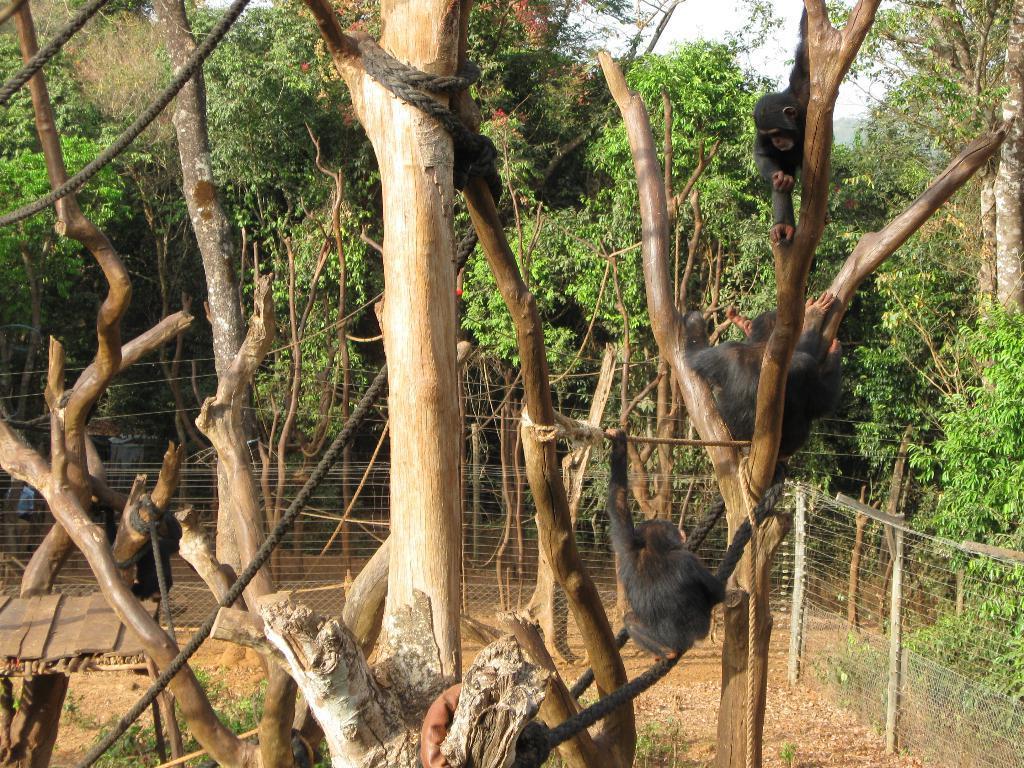Can you describe this image briefly? On this tree there are monkeys. These are ropes. Around this tree there is a fence. Background there are trees. 